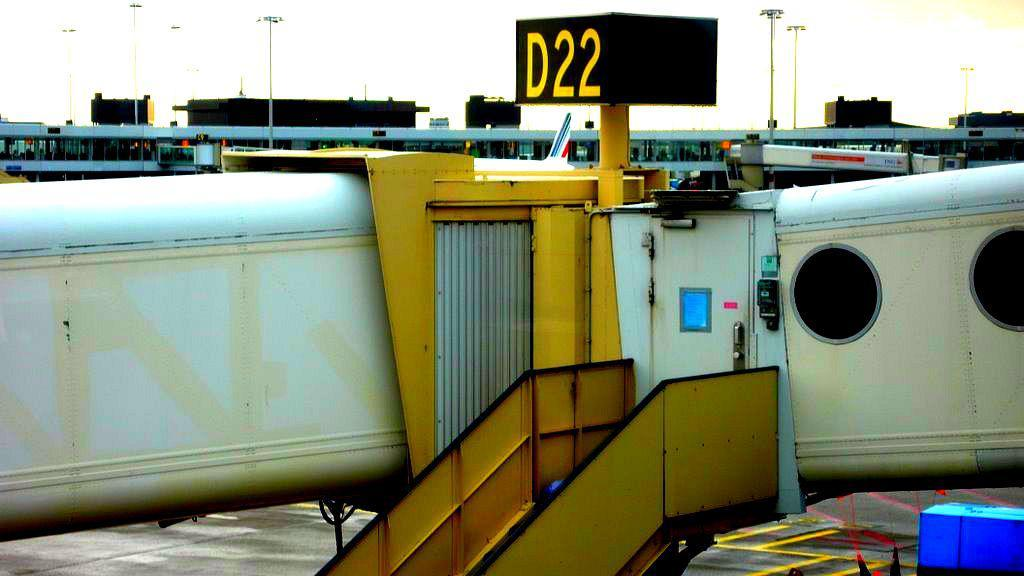<image>
Present a compact description of the photo's key features. Gate D22 is shown outdoors and is ready for boarding. 